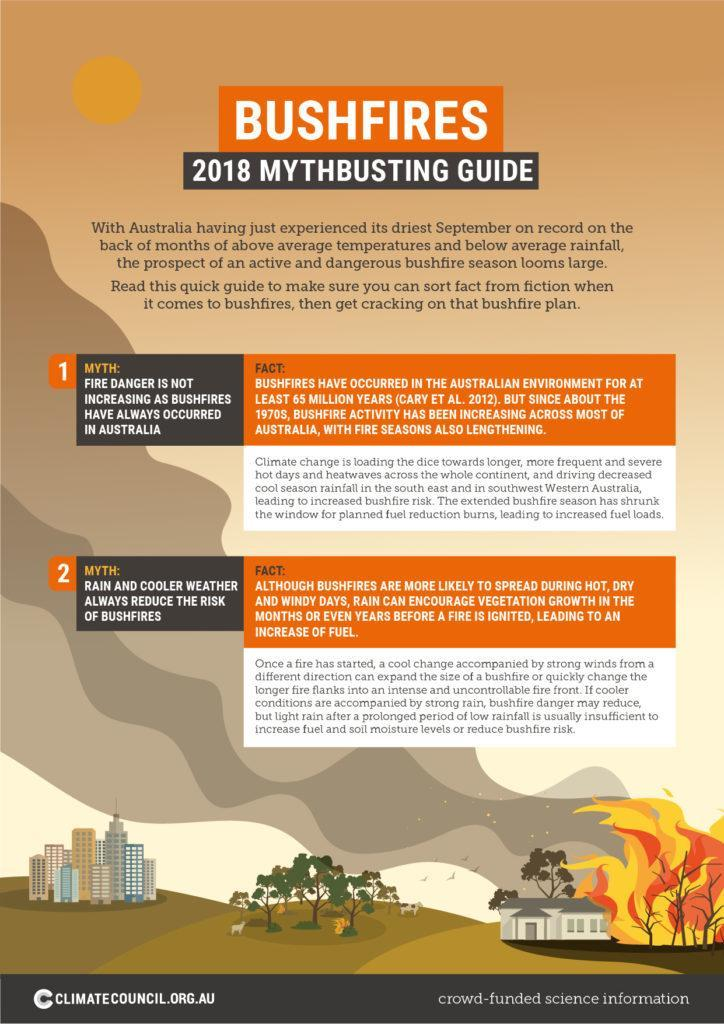what is rain and cooler weather always reduce the risk of bushfires
Answer the question with a short phrase. myth what is increasing heatwaves climate change what has increased fuel loads extended bushfire season 